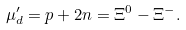<formula> <loc_0><loc_0><loc_500><loc_500>\mu ^ { \prime } _ { d } = p + 2 n = \Xi ^ { 0 } - \Xi ^ { - } .</formula> 